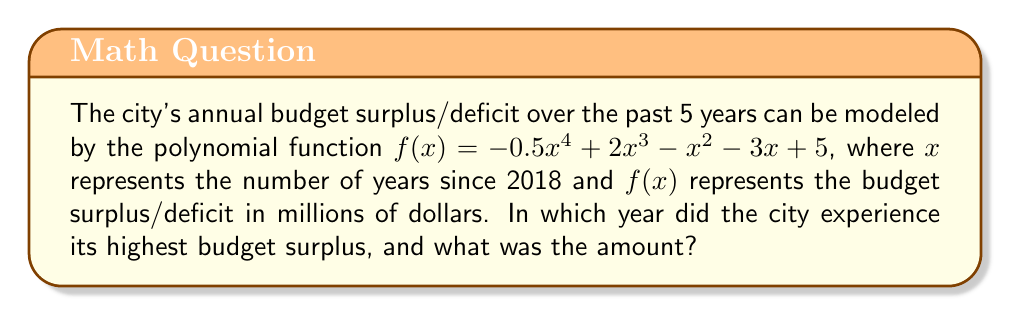Can you solve this math problem? To solve this problem, we need to follow these steps:

1) The domain of our function is $x = 0, 1, 2, 3, 4, 5$, representing the years 2018 to 2023.

2) Calculate $f(x)$ for each year:

   For 2018 ($x = 0$): 
   $f(0) = -0.5(0)^4 + 2(0)^3 - (0)^2 - 3(0) + 5 = 5$ million

   For 2019 ($x = 1$):
   $f(1) = -0.5(1)^4 + 2(1)^3 - (1)^2 - 3(1) + 5 = -0.5 + 2 - 1 - 3 + 5 = 2.5$ million

   For 2020 ($x = 2$):
   $f(2) = -0.5(2)^4 + 2(2)^3 - (2)^2 - 3(2) + 5 = -8 + 16 - 4 - 6 + 5 = 3$ million

   For 2021 ($x = 3$):
   $f(3) = -0.5(3)^4 + 2(3)^3 - (3)^2 - 3(3) + 5 = -40.5 + 54 - 9 - 9 + 5 = 0.5$ million

   For 2022 ($x = 4$):
   $f(4) = -0.5(4)^4 + 2(4)^3 - (4)^2 - 3(4) + 5 = -128 + 128 - 16 - 12 + 5 = -23$ million

   For 2023 ($x = 5$):
   $f(5) = -0.5(5)^4 + 2(5)^3 - (5)^2 - 3(5) + 5 = -312.5 + 250 - 25 - 15 + 5 = -97.5$ million

3) The highest value among these is 5 million, which occurred when $x = 0$, corresponding to 2018.

Therefore, the city experienced its highest budget surplus in 2018, and the amount was 5 million dollars.
Answer: 2018; $5 million 